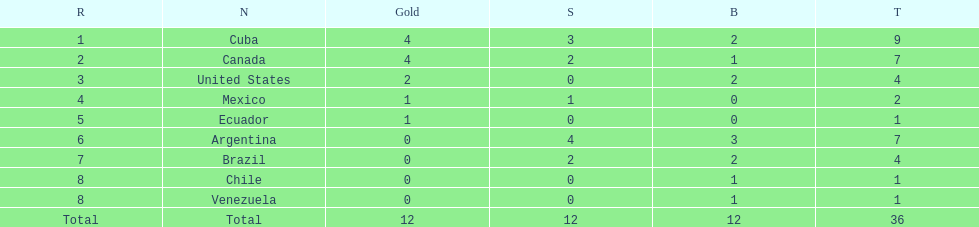Between cuba and brazil, which country had a greater number of silver medals? Cuba. 